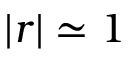<formula> <loc_0><loc_0><loc_500><loc_500>| r | \simeq 1</formula> 